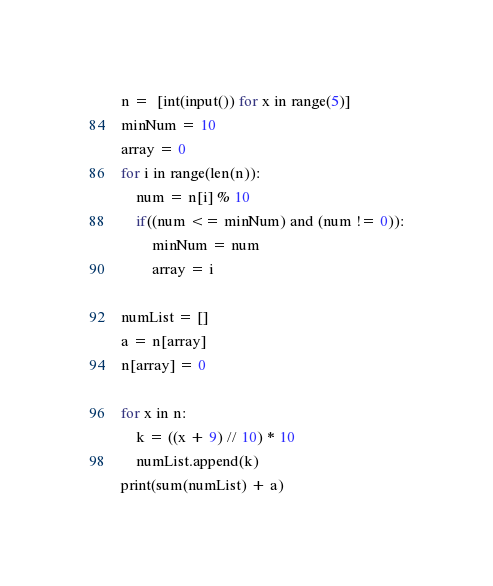<code> <loc_0><loc_0><loc_500><loc_500><_Python_>n =  [int(input()) for x in range(5)]
minNum = 10
array = 0
for i in range(len(n)):
    num = n[i] % 10
    if((num <= minNum) and (num != 0)):
        minNum = num
        array = i
        
numList = []
a = n[array]
n[array] = 0

for x in n:
    k = ((x + 9) // 10) * 10
    numList.append(k)  
print(sum(numList) + a)</code> 